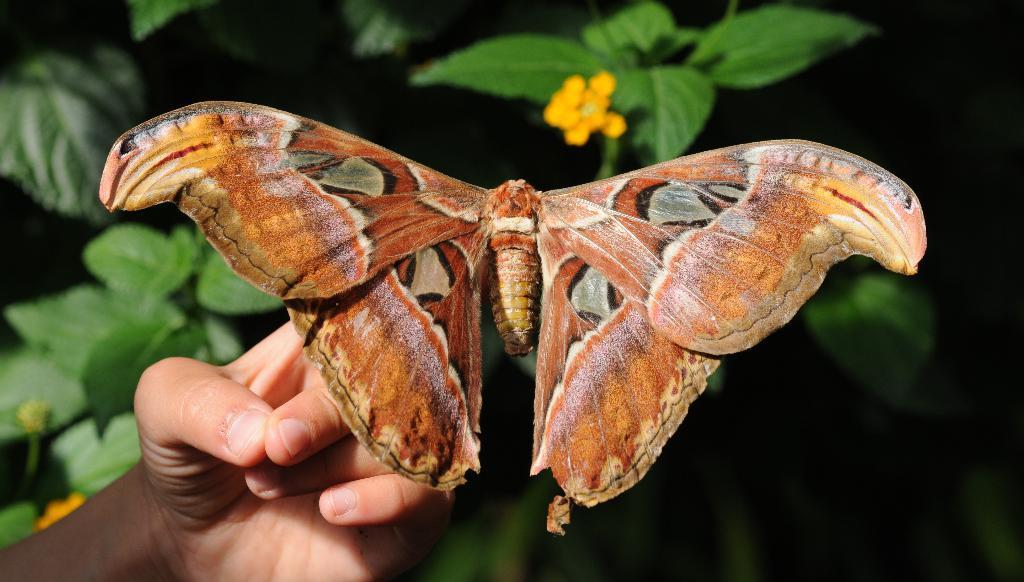Describe this image in one or two sentences. In this image in front there is a butterfly on the hand of a person. In the background of the image there are leaves and flowers. 